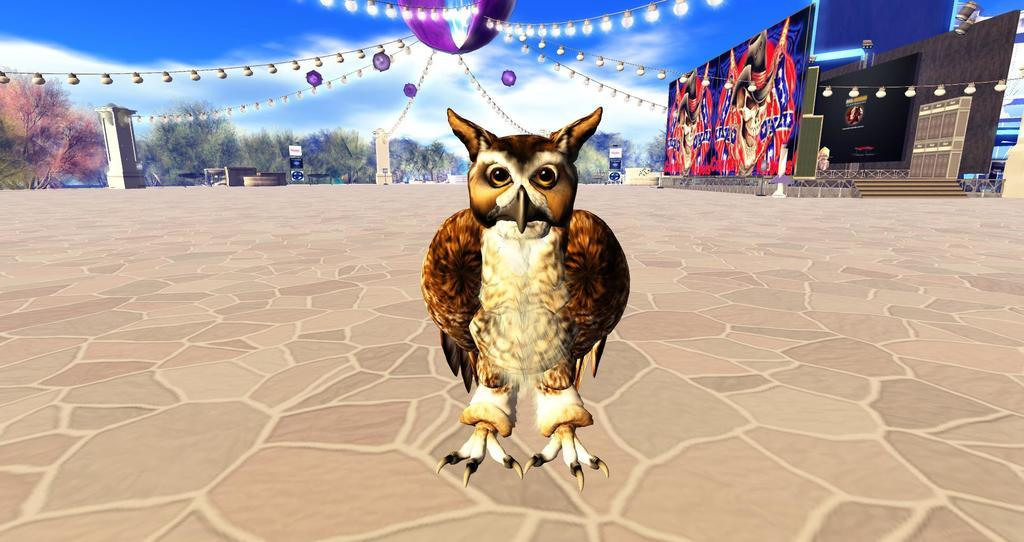What type of image is being described? The image is a cartoon. What is the main subject of the cartoon? There is an owl in the center of the image. What can be seen in the background of the cartoon? There are daisies, lighting, trees, the sky, and clouds present in the background of the image. How many goldfish are swimming in the sky in the image? There are no goldfish present in the image; the sky contains clouds instead. 